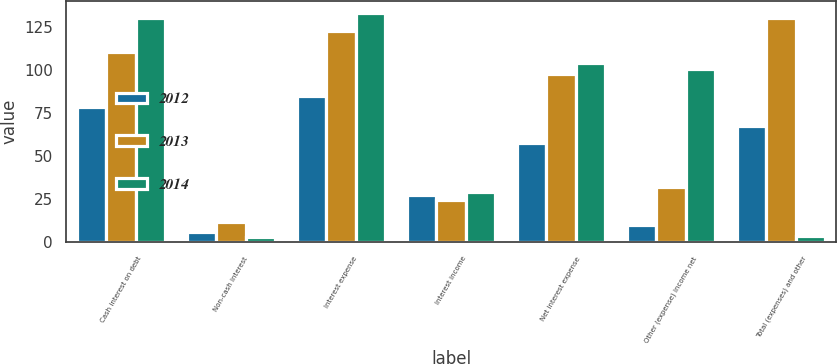<chart> <loc_0><loc_0><loc_500><loc_500><stacked_bar_chart><ecel><fcel>Cash interest on debt<fcel>Non-cash interest<fcel>Interest expense<fcel>Interest income<fcel>Net interest expense<fcel>Other (expense) income net<fcel>Total (expenses) and other<nl><fcel>2012<fcel>78.9<fcel>6<fcel>84.9<fcel>27.4<fcel>57.5<fcel>10.2<fcel>67.7<nl><fcel>2013<fcel>110.7<fcel>12<fcel>122.7<fcel>24.7<fcel>98<fcel>32.3<fcel>130.3<nl><fcel>2014<fcel>130.6<fcel>2.9<fcel>133.5<fcel>29.5<fcel>104<fcel>100.5<fcel>3.5<nl></chart> 